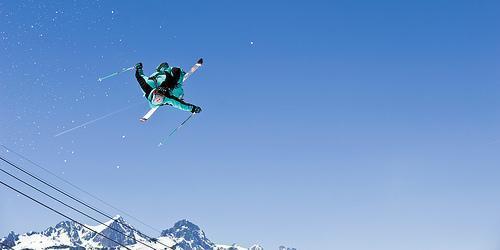How many people are there?
Give a very brief answer. 1. How many hang gliders are in this photo?
Give a very brief answer. 0. 